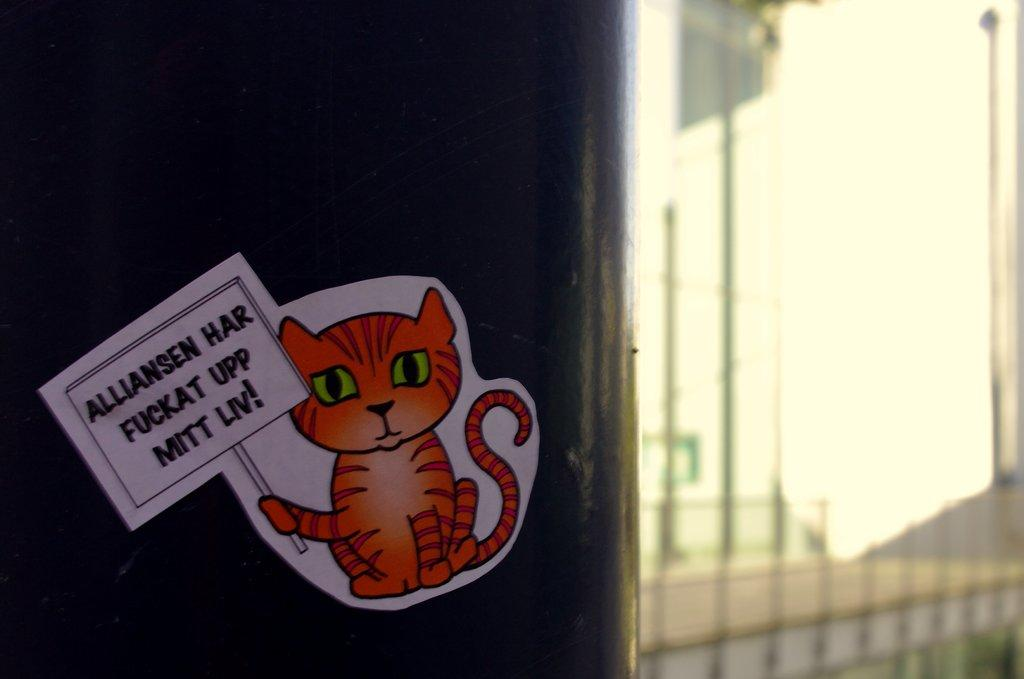What is depicted on the sticker in the image? There is a sticker of a cat holding a board in the image. What can be seen on the right side of the image? There are a few objects on the right side of the image, and there is a blurred view. What is the minister's desire on the page in the image? There is no minister, desire, or page present in the image. 